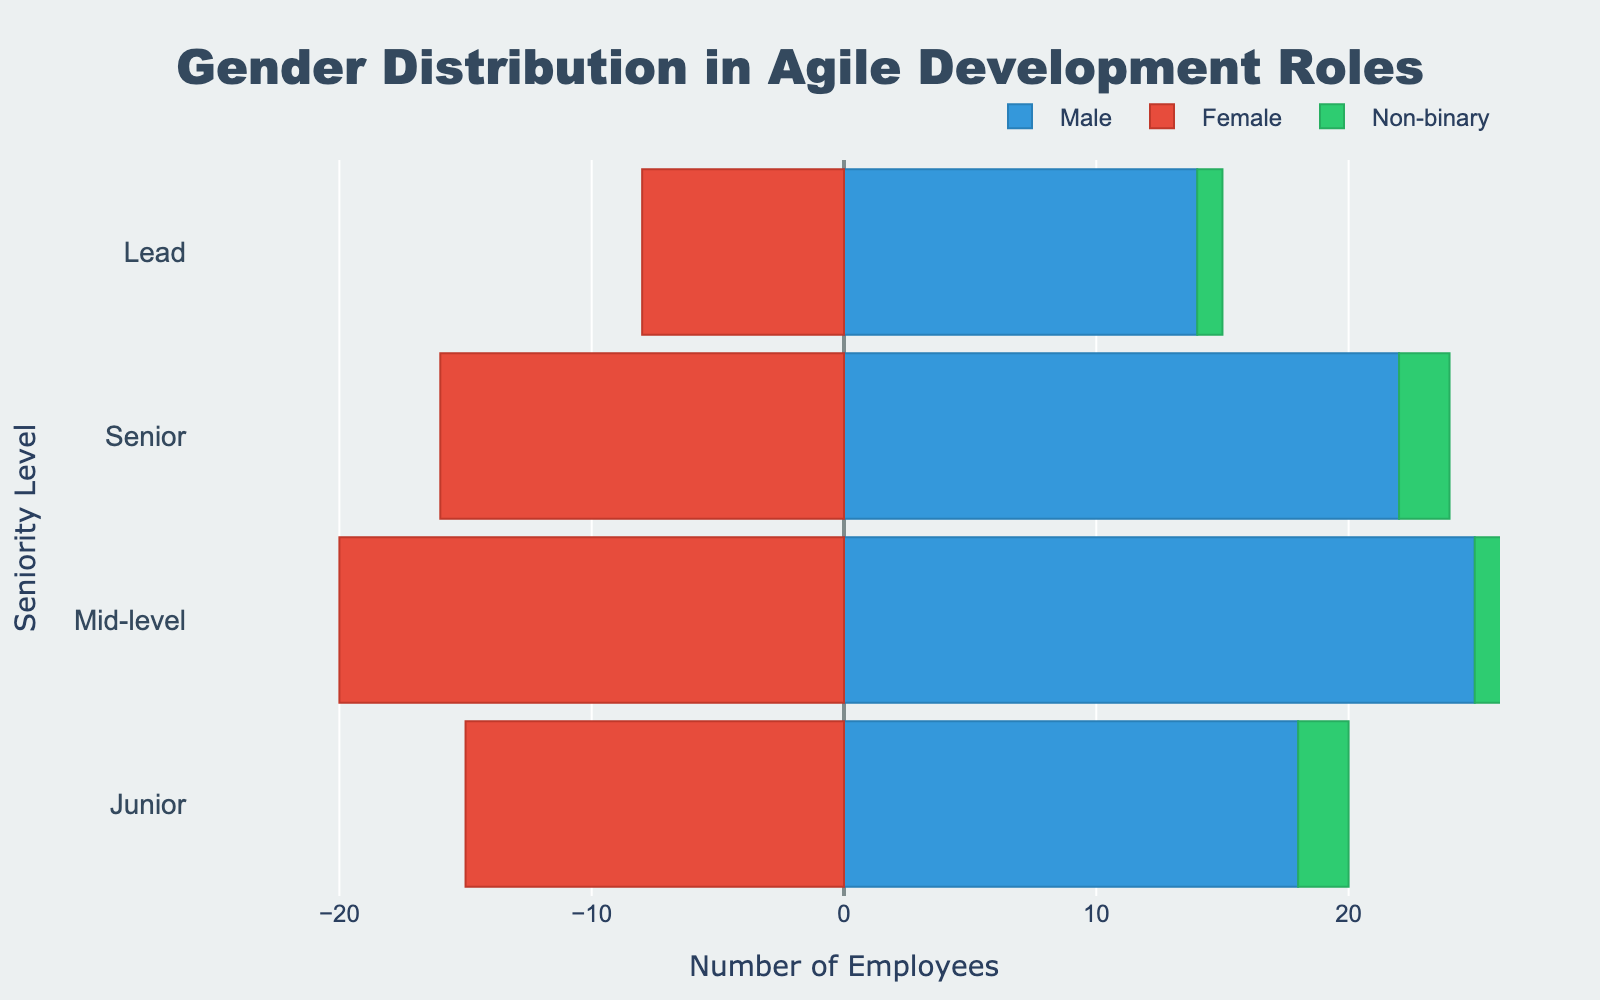What's the title of the figure? The title is usually positioned at the top of the figure. It helps in understanding the general content or focus of the graph. In this case, the title is centrally positioned at the top.
Answer: Gender Distribution in Agile Development Roles How many seniority levels are shown on the vertical axis? Look at the left side of the figure where the vertical axis is labeled. Each label corresponds to a seniority level. Count these labels.
Answer: 4 Which gender has the highest number of employees at the Senior level? Identify the bars representing the Senior level for each gender. Compare their lengths to determine which one is the longest.
Answer: Male What's the total number of Female employees across all seniority levels? Add up the absolute values of the bars on the negative side of the x-axis for the Female category at each level: Junior (15) + Mid-level (20) + Senior (16) + Lead (8).
Answer: 59 What's the total number of employees at the Lead level? Sum up the employees represented by each bar at the Lead level: Male (14) + Female (8) + Non-binary (1).
Answer: 23 How many more Male employees are there than Female employees at the Mid-level? Subtract the number of Female employees from the number of Male employees at Mid-level: 25 (Male) - 20 (Female).
Answer: 5 What's the proportion of Non-binary employees at the Junior level relative to the total Junior level population? Find the Non-binary employees at the Junior level (2) and divide by the total number of Junior employees (Male + Female + Non-binary): (18 + 15 + 2) = 35. Proportion is 2/35.
Answer: 2/35 Which Gender has the smallest representation at the Lead level? Look at the length of the bars at the Lead level for each gender. The shortest bar represents the smallest representation.
Answer: Non-binary How does the number of Female employees change as the seniority level increases? Examine the lengths of the Female bars (negative side) starting from Junior to Lead. Observe the trend: Junior (15), Mid-level (20), Senior (16), and Lead (8).
Answer: Decreases What's the average number of Male employees across all seniority levels? Sum the Male employees at each level and divide by the number of levels: (18 + 25 + 22 + 14) / 4.
Answer: 19.75 